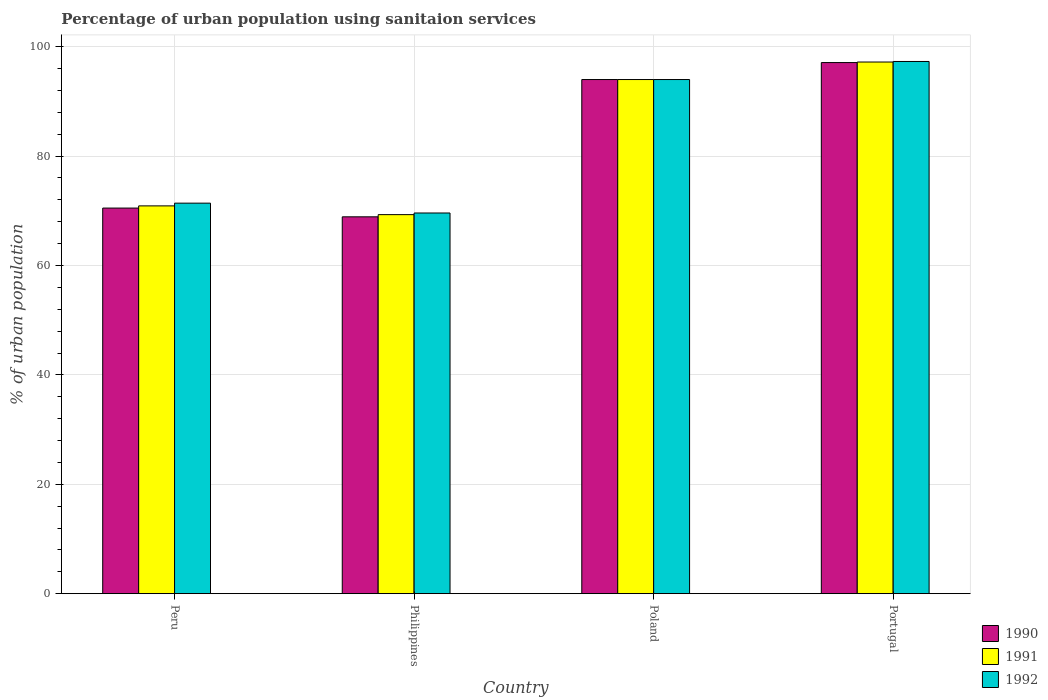How many different coloured bars are there?
Ensure brevity in your answer.  3. How many groups of bars are there?
Your response must be concise. 4. What is the percentage of urban population using sanitaion services in 1990 in Portugal?
Offer a very short reply. 97.1. Across all countries, what is the maximum percentage of urban population using sanitaion services in 1990?
Your response must be concise. 97.1. Across all countries, what is the minimum percentage of urban population using sanitaion services in 1991?
Provide a succinct answer. 69.3. In which country was the percentage of urban population using sanitaion services in 1990 maximum?
Provide a succinct answer. Portugal. In which country was the percentage of urban population using sanitaion services in 1991 minimum?
Ensure brevity in your answer.  Philippines. What is the total percentage of urban population using sanitaion services in 1990 in the graph?
Ensure brevity in your answer.  330.5. What is the difference between the percentage of urban population using sanitaion services in 1990 in Poland and that in Portugal?
Keep it short and to the point. -3.1. What is the difference between the percentage of urban population using sanitaion services in 1991 in Peru and the percentage of urban population using sanitaion services in 1992 in Philippines?
Provide a short and direct response. 1.3. What is the average percentage of urban population using sanitaion services in 1990 per country?
Your answer should be compact. 82.62. In how many countries, is the percentage of urban population using sanitaion services in 1991 greater than 44 %?
Make the answer very short. 4. What is the ratio of the percentage of urban population using sanitaion services in 1992 in Philippines to that in Portugal?
Ensure brevity in your answer.  0.72. Is the percentage of urban population using sanitaion services in 1990 in Peru less than that in Portugal?
Provide a succinct answer. Yes. What is the difference between the highest and the second highest percentage of urban population using sanitaion services in 1992?
Make the answer very short. 3.3. What is the difference between the highest and the lowest percentage of urban population using sanitaion services in 1990?
Offer a very short reply. 28.2. In how many countries, is the percentage of urban population using sanitaion services in 1991 greater than the average percentage of urban population using sanitaion services in 1991 taken over all countries?
Give a very brief answer. 2. Is the sum of the percentage of urban population using sanitaion services in 1992 in Philippines and Poland greater than the maximum percentage of urban population using sanitaion services in 1990 across all countries?
Your response must be concise. Yes. Is it the case that in every country, the sum of the percentage of urban population using sanitaion services in 1990 and percentage of urban population using sanitaion services in 1992 is greater than the percentage of urban population using sanitaion services in 1991?
Your response must be concise. Yes. How many bars are there?
Provide a short and direct response. 12. Are all the bars in the graph horizontal?
Make the answer very short. No. Are the values on the major ticks of Y-axis written in scientific E-notation?
Keep it short and to the point. No. Where does the legend appear in the graph?
Offer a terse response. Bottom right. How many legend labels are there?
Keep it short and to the point. 3. How are the legend labels stacked?
Your answer should be very brief. Vertical. What is the title of the graph?
Keep it short and to the point. Percentage of urban population using sanitaion services. What is the label or title of the Y-axis?
Ensure brevity in your answer.  % of urban population. What is the % of urban population of 1990 in Peru?
Ensure brevity in your answer.  70.5. What is the % of urban population in 1991 in Peru?
Ensure brevity in your answer.  70.9. What is the % of urban population in 1992 in Peru?
Offer a terse response. 71.4. What is the % of urban population of 1990 in Philippines?
Your answer should be compact. 68.9. What is the % of urban population in 1991 in Philippines?
Your answer should be compact. 69.3. What is the % of urban population of 1992 in Philippines?
Give a very brief answer. 69.6. What is the % of urban population in 1990 in Poland?
Offer a terse response. 94. What is the % of urban population in 1991 in Poland?
Offer a terse response. 94. What is the % of urban population in 1992 in Poland?
Ensure brevity in your answer.  94. What is the % of urban population of 1990 in Portugal?
Offer a terse response. 97.1. What is the % of urban population of 1991 in Portugal?
Offer a terse response. 97.2. What is the % of urban population of 1992 in Portugal?
Offer a terse response. 97.3. Across all countries, what is the maximum % of urban population in 1990?
Provide a short and direct response. 97.1. Across all countries, what is the maximum % of urban population of 1991?
Provide a succinct answer. 97.2. Across all countries, what is the maximum % of urban population in 1992?
Offer a very short reply. 97.3. Across all countries, what is the minimum % of urban population in 1990?
Offer a very short reply. 68.9. Across all countries, what is the minimum % of urban population in 1991?
Make the answer very short. 69.3. Across all countries, what is the minimum % of urban population in 1992?
Offer a terse response. 69.6. What is the total % of urban population in 1990 in the graph?
Ensure brevity in your answer.  330.5. What is the total % of urban population in 1991 in the graph?
Give a very brief answer. 331.4. What is the total % of urban population in 1992 in the graph?
Provide a short and direct response. 332.3. What is the difference between the % of urban population in 1990 in Peru and that in Philippines?
Ensure brevity in your answer.  1.6. What is the difference between the % of urban population in 1991 in Peru and that in Philippines?
Your response must be concise. 1.6. What is the difference between the % of urban population of 1990 in Peru and that in Poland?
Keep it short and to the point. -23.5. What is the difference between the % of urban population of 1991 in Peru and that in Poland?
Ensure brevity in your answer.  -23.1. What is the difference between the % of urban population in 1992 in Peru and that in Poland?
Ensure brevity in your answer.  -22.6. What is the difference between the % of urban population of 1990 in Peru and that in Portugal?
Your answer should be compact. -26.6. What is the difference between the % of urban population of 1991 in Peru and that in Portugal?
Provide a succinct answer. -26.3. What is the difference between the % of urban population in 1992 in Peru and that in Portugal?
Provide a succinct answer. -25.9. What is the difference between the % of urban population in 1990 in Philippines and that in Poland?
Give a very brief answer. -25.1. What is the difference between the % of urban population in 1991 in Philippines and that in Poland?
Provide a short and direct response. -24.7. What is the difference between the % of urban population of 1992 in Philippines and that in Poland?
Your answer should be compact. -24.4. What is the difference between the % of urban population in 1990 in Philippines and that in Portugal?
Give a very brief answer. -28.2. What is the difference between the % of urban population of 1991 in Philippines and that in Portugal?
Offer a terse response. -27.9. What is the difference between the % of urban population of 1992 in Philippines and that in Portugal?
Ensure brevity in your answer.  -27.7. What is the difference between the % of urban population of 1991 in Poland and that in Portugal?
Provide a short and direct response. -3.2. What is the difference between the % of urban population in 1990 in Peru and the % of urban population in 1991 in Philippines?
Offer a very short reply. 1.2. What is the difference between the % of urban population of 1990 in Peru and the % of urban population of 1992 in Philippines?
Give a very brief answer. 0.9. What is the difference between the % of urban population in 1990 in Peru and the % of urban population in 1991 in Poland?
Offer a very short reply. -23.5. What is the difference between the % of urban population in 1990 in Peru and the % of urban population in 1992 in Poland?
Your response must be concise. -23.5. What is the difference between the % of urban population of 1991 in Peru and the % of urban population of 1992 in Poland?
Offer a terse response. -23.1. What is the difference between the % of urban population in 1990 in Peru and the % of urban population in 1991 in Portugal?
Ensure brevity in your answer.  -26.7. What is the difference between the % of urban population of 1990 in Peru and the % of urban population of 1992 in Portugal?
Offer a terse response. -26.8. What is the difference between the % of urban population in 1991 in Peru and the % of urban population in 1992 in Portugal?
Offer a terse response. -26.4. What is the difference between the % of urban population in 1990 in Philippines and the % of urban population in 1991 in Poland?
Your answer should be very brief. -25.1. What is the difference between the % of urban population of 1990 in Philippines and the % of urban population of 1992 in Poland?
Offer a terse response. -25.1. What is the difference between the % of urban population in 1991 in Philippines and the % of urban population in 1992 in Poland?
Make the answer very short. -24.7. What is the difference between the % of urban population of 1990 in Philippines and the % of urban population of 1991 in Portugal?
Ensure brevity in your answer.  -28.3. What is the difference between the % of urban population in 1990 in Philippines and the % of urban population in 1992 in Portugal?
Offer a terse response. -28.4. What is the difference between the % of urban population of 1991 in Philippines and the % of urban population of 1992 in Portugal?
Provide a short and direct response. -28. What is the difference between the % of urban population of 1990 in Poland and the % of urban population of 1992 in Portugal?
Give a very brief answer. -3.3. What is the difference between the % of urban population of 1991 in Poland and the % of urban population of 1992 in Portugal?
Keep it short and to the point. -3.3. What is the average % of urban population in 1990 per country?
Ensure brevity in your answer.  82.62. What is the average % of urban population in 1991 per country?
Your response must be concise. 82.85. What is the average % of urban population of 1992 per country?
Give a very brief answer. 83.08. What is the difference between the % of urban population of 1990 and % of urban population of 1992 in Peru?
Your answer should be very brief. -0.9. What is the difference between the % of urban population of 1991 and % of urban population of 1992 in Peru?
Give a very brief answer. -0.5. What is the difference between the % of urban population in 1990 and % of urban population in 1991 in Philippines?
Ensure brevity in your answer.  -0.4. What is the difference between the % of urban population in 1990 and % of urban population in 1992 in Philippines?
Your response must be concise. -0.7. What is the difference between the % of urban population in 1990 and % of urban population in 1991 in Poland?
Keep it short and to the point. 0. What is the difference between the % of urban population of 1990 and % of urban population of 1991 in Portugal?
Make the answer very short. -0.1. What is the ratio of the % of urban population in 1990 in Peru to that in Philippines?
Ensure brevity in your answer.  1.02. What is the ratio of the % of urban population of 1991 in Peru to that in Philippines?
Offer a very short reply. 1.02. What is the ratio of the % of urban population in 1992 in Peru to that in Philippines?
Offer a terse response. 1.03. What is the ratio of the % of urban population of 1990 in Peru to that in Poland?
Give a very brief answer. 0.75. What is the ratio of the % of urban population in 1991 in Peru to that in Poland?
Keep it short and to the point. 0.75. What is the ratio of the % of urban population in 1992 in Peru to that in Poland?
Keep it short and to the point. 0.76. What is the ratio of the % of urban population in 1990 in Peru to that in Portugal?
Offer a terse response. 0.73. What is the ratio of the % of urban population in 1991 in Peru to that in Portugal?
Offer a very short reply. 0.73. What is the ratio of the % of urban population in 1992 in Peru to that in Portugal?
Your response must be concise. 0.73. What is the ratio of the % of urban population of 1990 in Philippines to that in Poland?
Offer a very short reply. 0.73. What is the ratio of the % of urban population in 1991 in Philippines to that in Poland?
Give a very brief answer. 0.74. What is the ratio of the % of urban population of 1992 in Philippines to that in Poland?
Offer a very short reply. 0.74. What is the ratio of the % of urban population of 1990 in Philippines to that in Portugal?
Give a very brief answer. 0.71. What is the ratio of the % of urban population of 1991 in Philippines to that in Portugal?
Provide a short and direct response. 0.71. What is the ratio of the % of urban population in 1992 in Philippines to that in Portugal?
Give a very brief answer. 0.72. What is the ratio of the % of urban population in 1990 in Poland to that in Portugal?
Your answer should be compact. 0.97. What is the ratio of the % of urban population in 1991 in Poland to that in Portugal?
Your answer should be very brief. 0.97. What is the ratio of the % of urban population of 1992 in Poland to that in Portugal?
Offer a terse response. 0.97. What is the difference between the highest and the lowest % of urban population of 1990?
Your response must be concise. 28.2. What is the difference between the highest and the lowest % of urban population of 1991?
Your answer should be very brief. 27.9. What is the difference between the highest and the lowest % of urban population of 1992?
Give a very brief answer. 27.7. 